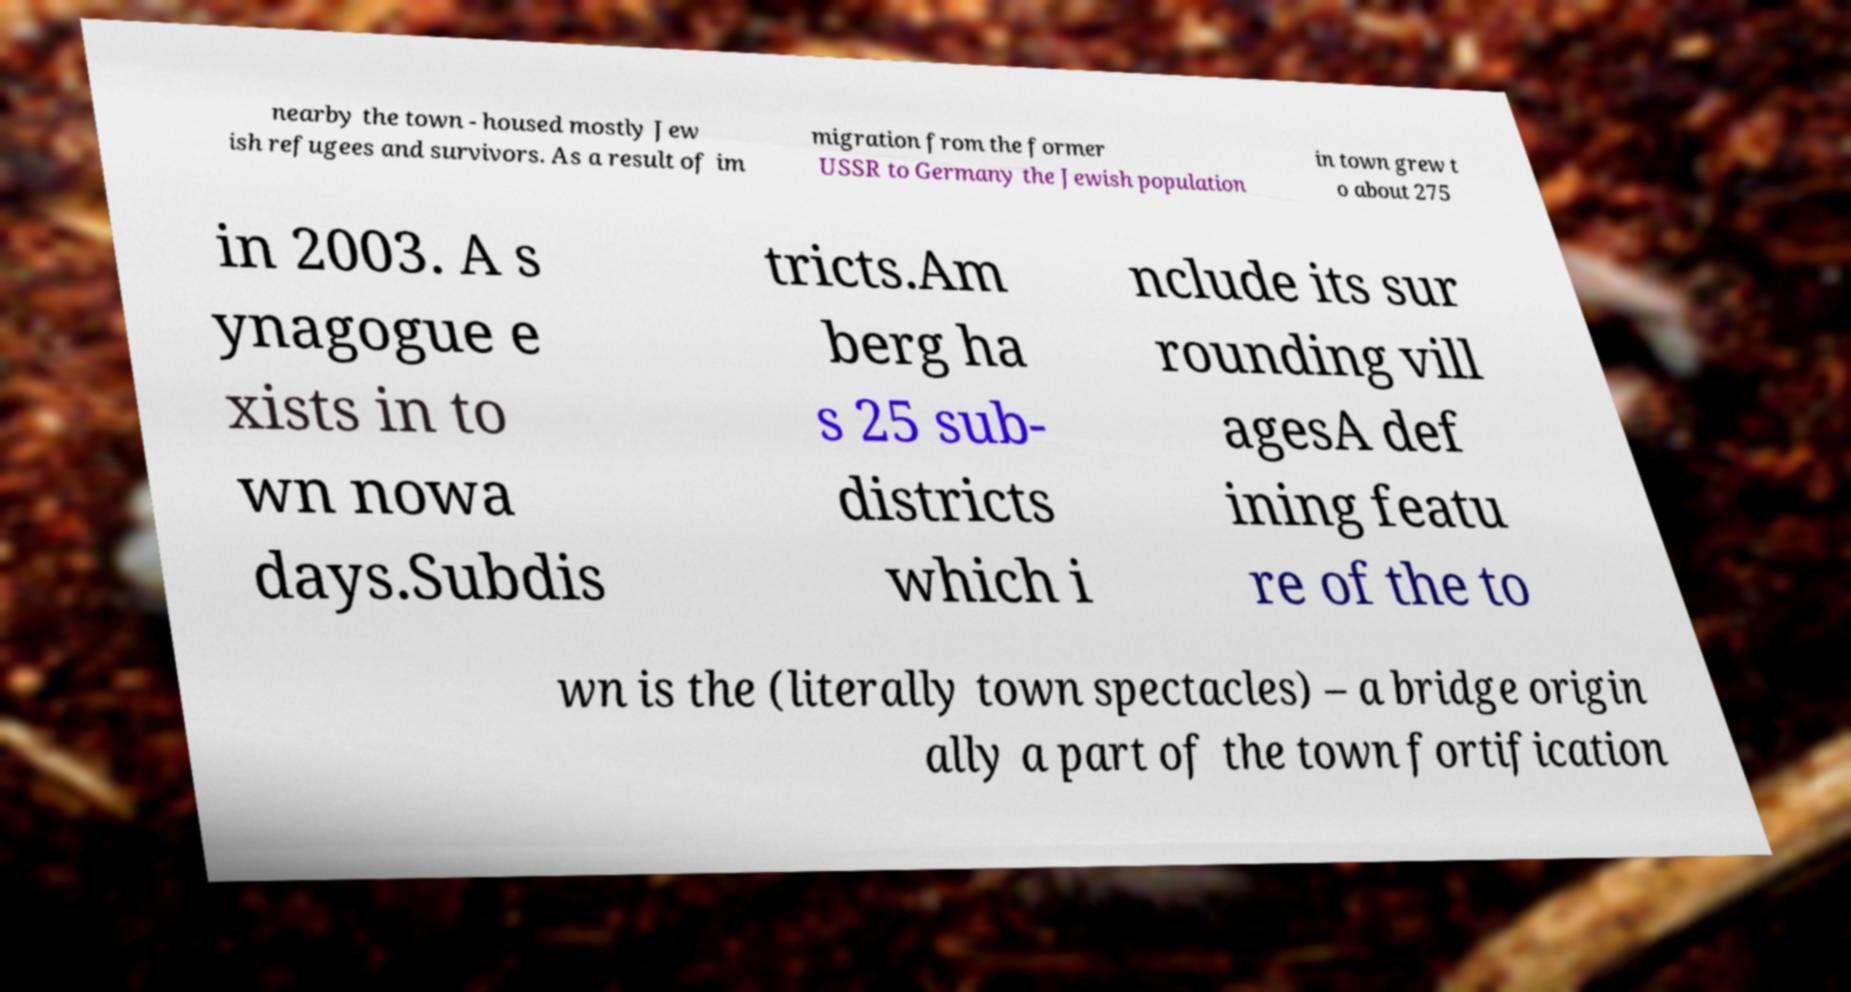Please identify and transcribe the text found in this image. nearby the town - housed mostly Jew ish refugees and survivors. As a result of im migration from the former USSR to Germany the Jewish population in town grew t o about 275 in 2003. A s ynagogue e xists in to wn nowa days.Subdis tricts.Am berg ha s 25 sub- districts which i nclude its sur rounding vill agesA def ining featu re of the to wn is the (literally town spectacles) – a bridge origin ally a part of the town fortification 